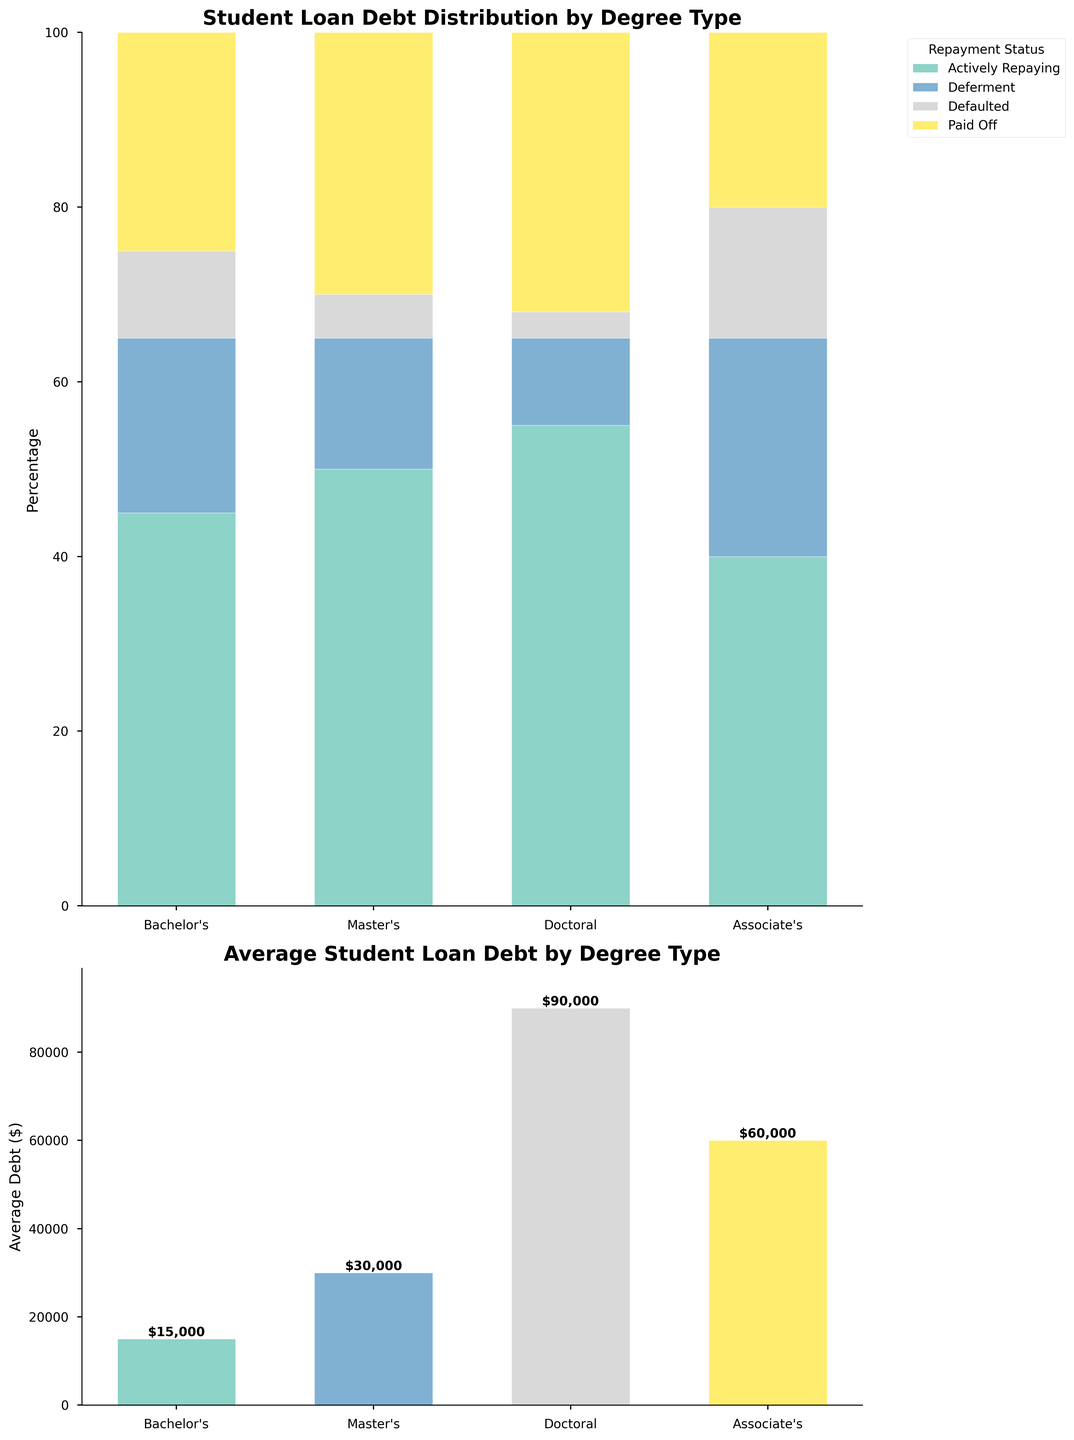What is the title of the first subplot? The title of the first subplot is given at the top of the chart, which says "Student Loan Debt Distribution by Degree Type".
Answer: Student Loan Debt Distribution by Degree Type Which degree type has the highest percentage of actively repaying status? In the first subplot, the Doctoral degree type has the tallest bar segment labeled "Actively Repaying", hence it has the highest percentage of that status.
Answer: Doctoral What is the average student loan debt for a Master's degree? In the second subplot, the bar for the Master's degree shows a height labeled with the average debt amount, which indicates $60,000.
Answer: $60,000 Which degree type has the smallest percentage in the 'Defaulted' repayment status? Observing the first subplot, the Doctoral degree type has the smallest segment for the 'Defaulted' status, indicated by a percentage of 3%.
Answer: Doctoral What is the total percentage of Bachelor's degree holders who are either in deferment or defaulted status? From the first subplot, the Bachelor's degree has 20% in deferment and 10% in defaulted status. Summing these gives 20 + 10 = 30%.
Answer: 30% Among all degree types, which repayment status has the most consistent percentage distribution across degrees? Looking at the first subplot, the 'Paid Off' status has fairly consistent segments across all degree types, especially compared to other statuses.
Answer: Paid Off How does the average student loan debt of an Associate's degree compare to a Doctoral degree? The second subplot shows the average debt for Associate's as $15,000 and Doctoral as $90,000. Comparing these, an Associate's degree has significantly lower average debt.
Answer: Associate's degree has lower debt Which degree type has the highest percentage of debt paid off? In the first subplot, the Doctoral degree's 'Paid Off' segment is the tallest among all degree types, with 32% paid off.
Answer: Doctoral Overall, which repayment status is most common for students with all types of degrees? Aggregating the heights of each status segment across all degree types in the first subplot, 'Actively Repaying' appears to have the most substantial combined height.
Answer: Actively Repaying 